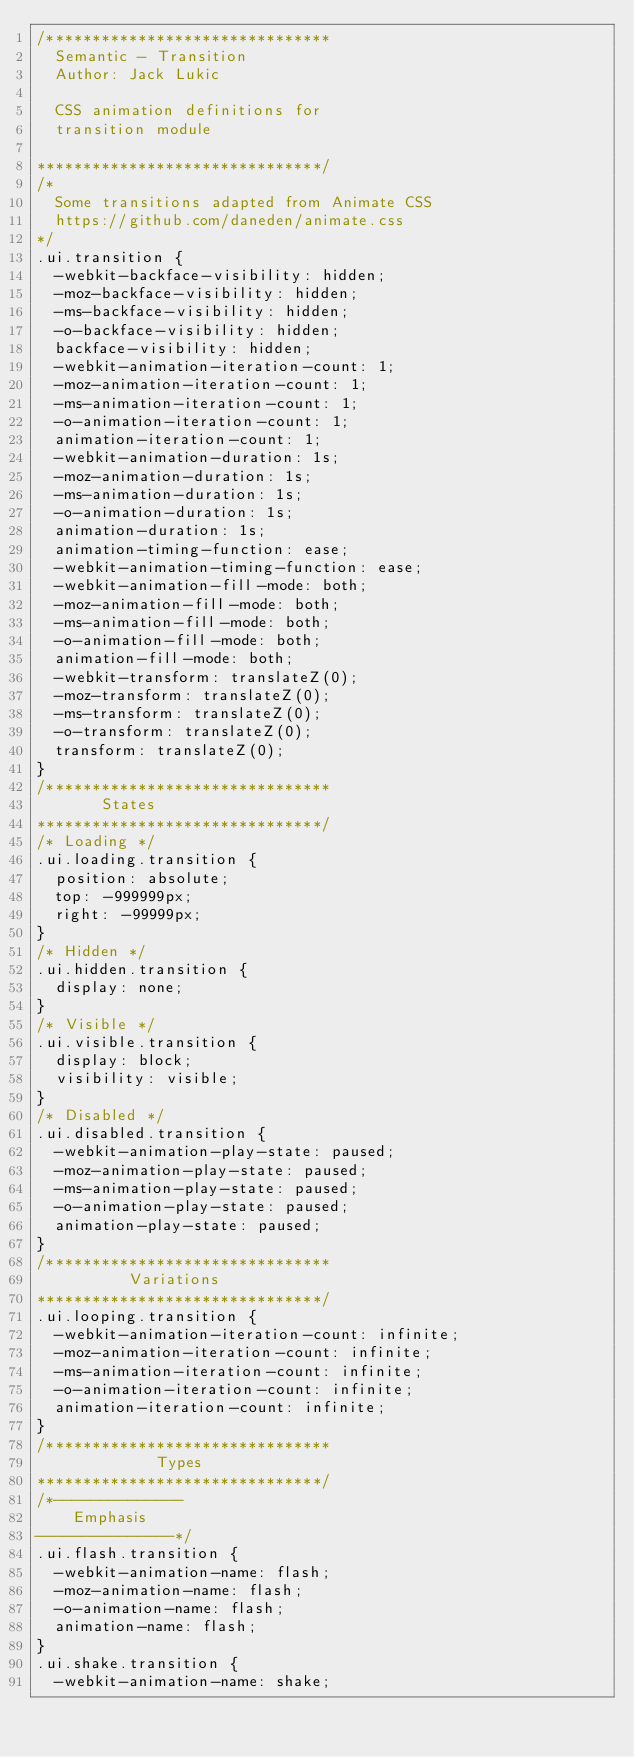<code> <loc_0><loc_0><loc_500><loc_500><_CSS_>/*******************************
  Semantic - Transition
  Author: Jack Lukic

  CSS animation definitions for
  transition module

*******************************/
/*
  Some transitions adapted from Animate CSS
  https://github.com/daneden/animate.css
*/
.ui.transition {
  -webkit-backface-visibility: hidden;
  -moz-backface-visibility: hidden;
  -ms-backface-visibility: hidden;
  -o-backface-visibility: hidden;
  backface-visibility: hidden;
  -webkit-animation-iteration-count: 1;
  -moz-animation-iteration-count: 1;
  -ms-animation-iteration-count: 1;
  -o-animation-iteration-count: 1;
  animation-iteration-count: 1;
  -webkit-animation-duration: 1s;
  -moz-animation-duration: 1s;
  -ms-animation-duration: 1s;
  -o-animation-duration: 1s;
  animation-duration: 1s;
  animation-timing-function: ease;
  -webkit-animation-timing-function: ease;
  -webkit-animation-fill-mode: both;
  -moz-animation-fill-mode: both;
  -ms-animation-fill-mode: both;
  -o-animation-fill-mode: both;
  animation-fill-mode: both;
  -webkit-transform: translateZ(0);
  -moz-transform: translateZ(0);
  -ms-transform: translateZ(0);
  -o-transform: translateZ(0);
  transform: translateZ(0);
}
/*******************************
       States
*******************************/
/* Loading */
.ui.loading.transition {
  position: absolute;
  top: -999999px;
  right: -99999px;
}
/* Hidden */
.ui.hidden.transition {
  display: none;
}
/* Visible */
.ui.visible.transition {
  display: block;
  visibility: visible;
}
/* Disabled */
.ui.disabled.transition {
  -webkit-animation-play-state: paused;
  -moz-animation-play-state: paused;
  -ms-animation-play-state: paused;
  -o-animation-play-state: paused;
  animation-play-state: paused;
}
/*******************************
          Variations
*******************************/
.ui.looping.transition {
  -webkit-animation-iteration-count: infinite;
  -moz-animation-iteration-count: infinite;
  -ms-animation-iteration-count: infinite;
  -o-animation-iteration-count: infinite;
  animation-iteration-count: infinite;
}
/*******************************
             Types
*******************************/
/*--------------
    Emphasis
---------------*/
.ui.flash.transition {
  -webkit-animation-name: flash;
  -moz-animation-name: flash;
  -o-animation-name: flash;
  animation-name: flash;
}
.ui.shake.transition {
  -webkit-animation-name: shake;</code> 